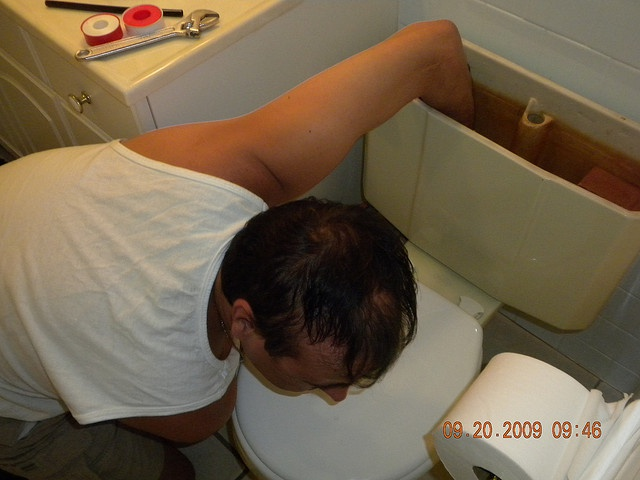Describe the objects in this image and their specific colors. I can see people in olive, black, darkgray, tan, and brown tones and toilet in olive and gray tones in this image. 